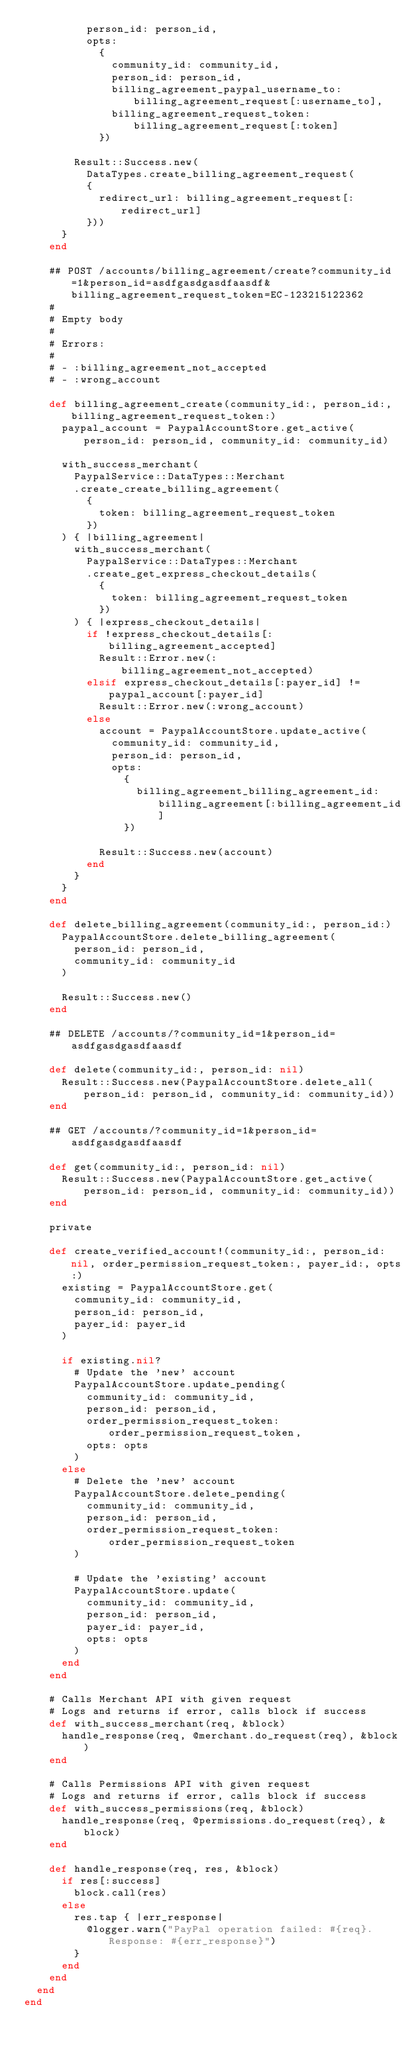<code> <loc_0><loc_0><loc_500><loc_500><_Ruby_>          person_id: person_id,
          opts:
            {
              community_id: community_id,
              person_id: person_id,
              billing_agreement_paypal_username_to: billing_agreement_request[:username_to],
              billing_agreement_request_token: billing_agreement_request[:token]
            })

        Result::Success.new(
          DataTypes.create_billing_agreement_request(
          {
            redirect_url: billing_agreement_request[:redirect_url]
          }))
      }
    end

    ## POST /accounts/billing_agreement/create?community_id=1&person_id=asdfgasdgasdfaasdf&billing_agreement_request_token=EC-123215122362
    #
    # Empty body
    #
    # Errors:
    #
    # - :billing_agreement_not_accepted
    # - :wrong_account

    def billing_agreement_create(community_id:, person_id:, billing_agreement_request_token:)
      paypal_account = PaypalAccountStore.get_active(person_id: person_id, community_id: community_id)

      with_success_merchant(
        PaypalService::DataTypes::Merchant
        .create_create_billing_agreement(
          {
            token: billing_agreement_request_token
          })
      ) { |billing_agreement|
        with_success_merchant(
          PaypalService::DataTypes::Merchant
          .create_get_express_checkout_details(
            {
              token: billing_agreement_request_token
            })
        ) { |express_checkout_details|
          if !express_checkout_details[:billing_agreement_accepted]
            Result::Error.new(:billing_agreement_not_accepted)
          elsif express_checkout_details[:payer_id] != paypal_account[:payer_id]
            Result::Error.new(:wrong_account)
          else
            account = PaypalAccountStore.update_active(
              community_id: community_id,
              person_id: person_id,
              opts:
                {
                  billing_agreement_billing_agreement_id: billing_agreement[:billing_agreement_id]
                })

            Result::Success.new(account)
          end
        }
      }
    end

    def delete_billing_agreement(community_id:, person_id:)
      PaypalAccountStore.delete_billing_agreement(
        person_id: person_id,
        community_id: community_id
      )

      Result::Success.new()
    end

    ## DELETE /accounts/?community_id=1&person_id=asdfgasdgasdfaasdf

    def delete(community_id:, person_id: nil)
      Result::Success.new(PaypalAccountStore.delete_all(person_id: person_id, community_id: community_id))
    end

    ## GET /accounts/?community_id=1&person_id=asdfgasdgasdfaasdf

    def get(community_id:, person_id: nil)
      Result::Success.new(PaypalAccountStore.get_active(person_id: person_id, community_id: community_id))
    end

    private

    def create_verified_account!(community_id:, person_id:nil, order_permission_request_token:, payer_id:, opts:)
      existing = PaypalAccountStore.get(
        community_id: community_id,
        person_id: person_id,
        payer_id: payer_id
      )

      if existing.nil?
        # Update the 'new' account
        PaypalAccountStore.update_pending(
          community_id: community_id,
          person_id: person_id,
          order_permission_request_token: order_permission_request_token,
          opts: opts
        )
      else
        # Delete the 'new' account
        PaypalAccountStore.delete_pending(
          community_id: community_id,
          person_id: person_id,
          order_permission_request_token: order_permission_request_token
        )

        # Update the 'existing' account
        PaypalAccountStore.update(
          community_id: community_id,
          person_id: person_id,
          payer_id: payer_id,
          opts: opts
        )
      end
    end

    # Calls Merchant API with given request
    # Logs and returns if error, calls block if success
    def with_success_merchant(req, &block)
      handle_response(req, @merchant.do_request(req), &block)
    end

    # Calls Permissions API with given request
    # Logs and returns if error, calls block if success
    def with_success_permissions(req, &block)
      handle_response(req, @permissions.do_request(req), &block)
    end

    def handle_response(req, res, &block)
      if res[:success]
        block.call(res)
      else
        res.tap { |err_response|
          @logger.warn("PayPal operation failed: #{req}. Response: #{err_response}")
        }
      end
    end
  end
end
</code> 